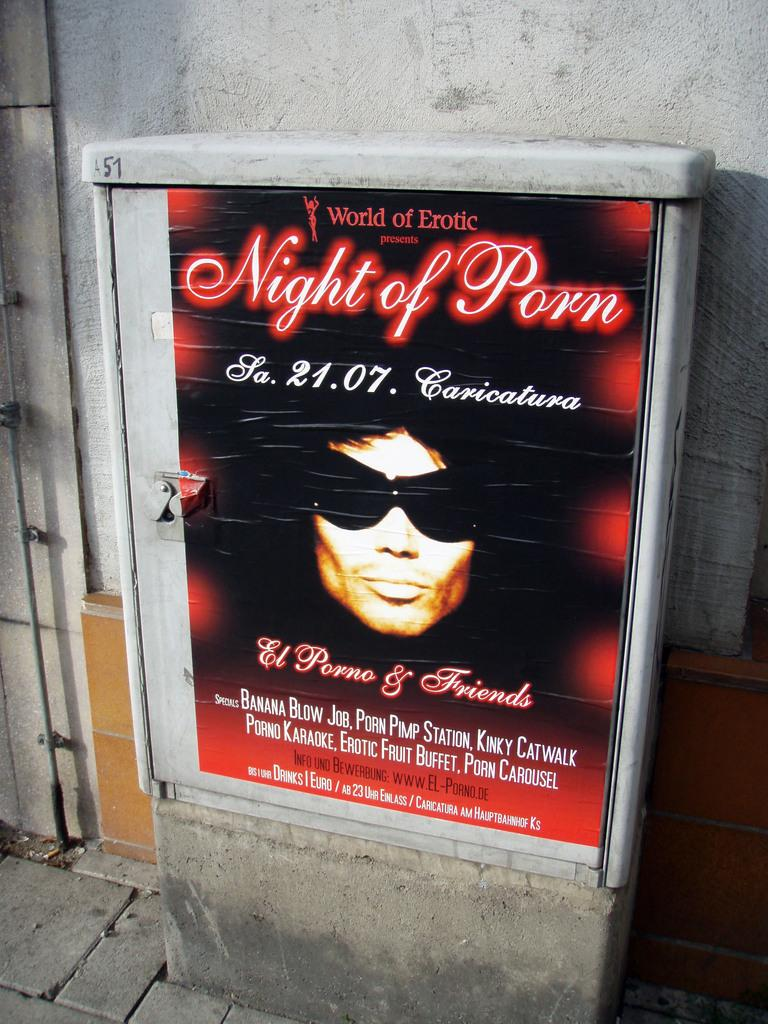Provide a one-sentence caption for the provided image. an advertisement saying night of porn with someone wearing sunglasses. 